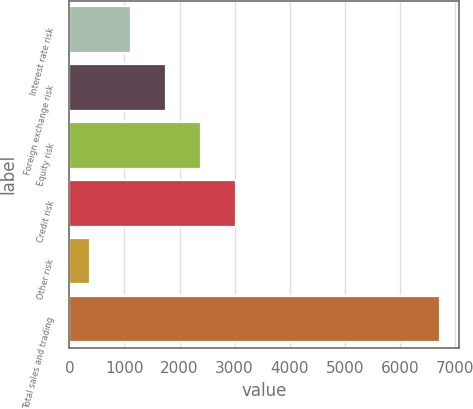Convert chart to OTSL. <chart><loc_0><loc_0><loc_500><loc_500><bar_chart><fcel>Interest rate risk<fcel>Foreign exchange risk<fcel>Equity risk<fcel>Credit risk<fcel>Other risk<fcel>Total sales and trading<nl><fcel>1120<fcel>1755.9<fcel>2391.8<fcel>3027.7<fcel>375<fcel>6734<nl></chart> 